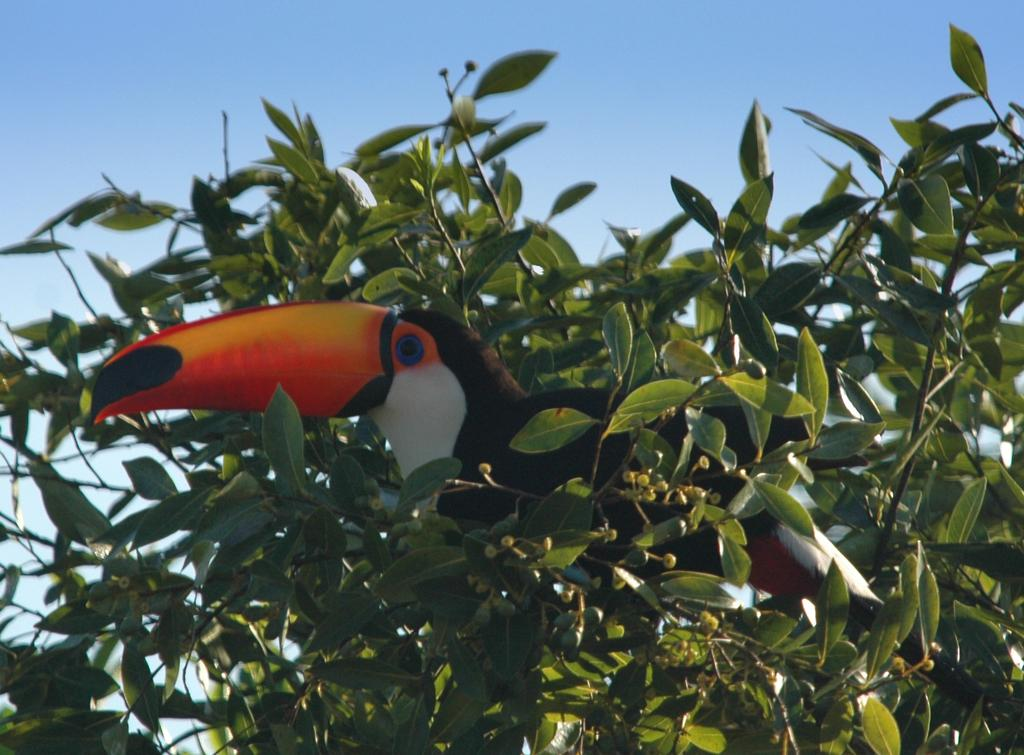What type of animal is on the tree in the image? There is a bird on the tree in the image. What are the buds with stems in the image? The buds with stems are likely flowers or leaves that are not yet fully grown. What can be seen in the background of the image? The sky is visible in the background of the image. What is the price of the hose in the image? There is no hose present in the image, so it is not possible to determine its price. 